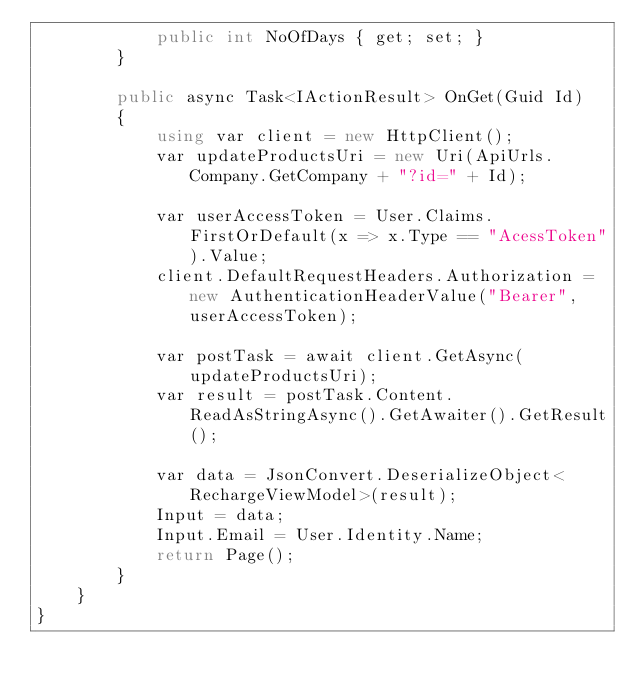<code> <loc_0><loc_0><loc_500><loc_500><_C#_>            public int NoOfDays { get; set; }
        }

        public async Task<IActionResult> OnGet(Guid Id)
        {
            using var client = new HttpClient();
            var updateProductsUri = new Uri(ApiUrls.Company.GetCompany + "?id=" + Id);

            var userAccessToken = User.Claims.FirstOrDefault(x => x.Type == "AcessToken").Value;
            client.DefaultRequestHeaders.Authorization = new AuthenticationHeaderValue("Bearer", userAccessToken);

            var postTask = await client.GetAsync(updateProductsUri);
            var result = postTask.Content.ReadAsStringAsync().GetAwaiter().GetResult();

            var data = JsonConvert.DeserializeObject<RechargeViewModel>(result);
            Input = data;
            Input.Email = User.Identity.Name;
            return Page();
        }
    }
}
</code> 